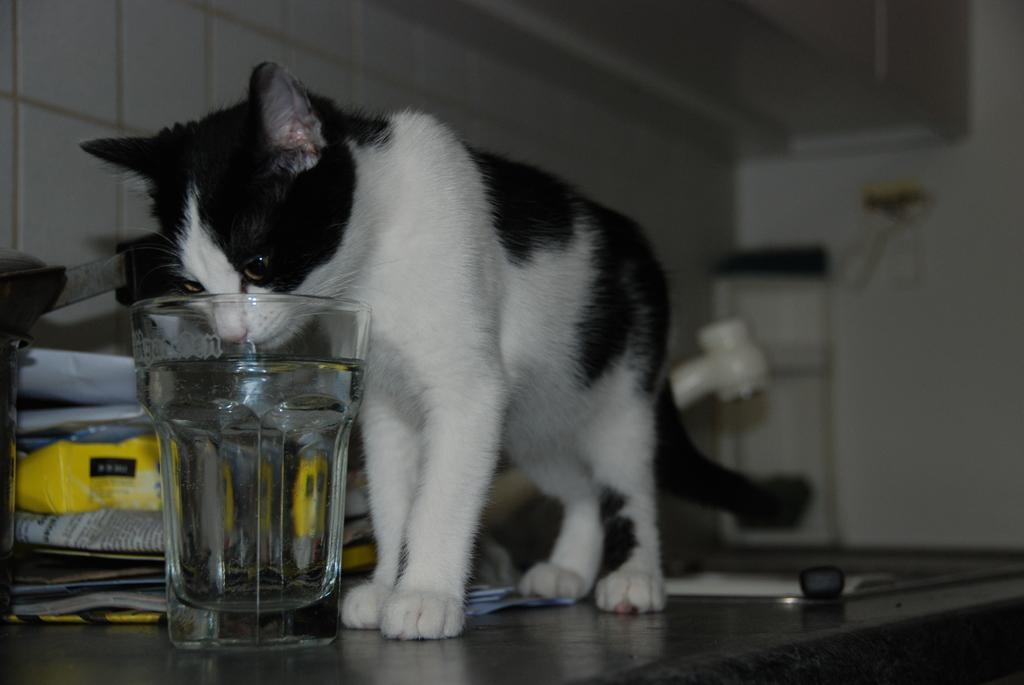What is located in the foreground of the image? There is a cat and a glass in the foreground of the image. What objects can be seen on the cabinet in the foreground? There are paper objects on a cabinet in the foreground of the image. What can be seen in the background of the image? There is a wash basin, a wall, and a door in the background of the image. Can you describe the setting of the image? The image might have been taken in a room, as it contains a wash basin, a wall, and a door in the background. What type of loaf is being prepared on the table in the image? There is no table or loaf present in the image; it features a cat, a glass, paper objects, a wash basin, a wall, and a door. Is there any blood visible on the cat in the image? There is no blood visible on the cat in the image. 